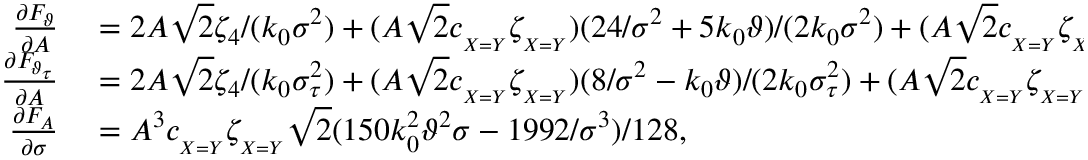Convert formula to latex. <formula><loc_0><loc_0><loc_500><loc_500>\begin{array} { r l } { \frac { \partial F _ { \vartheta } } { \partial A } } & = 2 A \sqrt { 2 } \zeta _ { 4 } / ( k _ { 0 } \sigma ^ { 2 } ) + ( A \sqrt { 2 } c _ { _ { X = Y } } \zeta _ { _ { X = Y } } ) ( 2 4 / \sigma ^ { 2 } + 5 k _ { 0 } \vartheta ) / ( 2 k _ { 0 } \sigma ^ { 2 } ) + ( A \sqrt { 2 } c _ { _ { X = Y } } \zeta _ { _ { X = Y } } ) ( 8 / \sigma ^ { 2 } - k _ { 0 } \vartheta ) / ( 2 k _ { 0 } \sigma ^ { 2 } ) , } \\ { \frac { \partial F _ { \vartheta _ { \tau } } } { \partial A } } & = 2 A \sqrt { 2 } \zeta _ { 4 } / ( k _ { 0 } \sigma _ { \tau } ^ { 2 } ) + ( A \sqrt { 2 } c _ { _ { X = Y } } \zeta _ { _ { X = Y } } ) ( 8 / \sigma ^ { 2 } - k _ { 0 } \vartheta ) / ( 2 k _ { 0 } \sigma _ { \tau } ^ { 2 } ) + ( A \sqrt { 2 } c _ { _ { X = Y } } \zeta _ { _ { X = Y } } ) ( 8 / \sigma ^ { 2 } - k _ { 0 } \vartheta ) / ( 2 k _ { 0 } \sigma _ { \tau } ^ { 2 } ) , } \\ { \frac { \partial F _ { A } } { \partial \sigma } } & = A ^ { 3 } c _ { _ { X = Y } } \zeta _ { _ { X = Y } } \sqrt { 2 } ( 1 5 0 k _ { 0 } ^ { 2 } \vartheta ^ { 2 } \sigma - 1 9 9 2 / \sigma ^ { 3 } ) / 1 2 8 , } \end{array}</formula> 